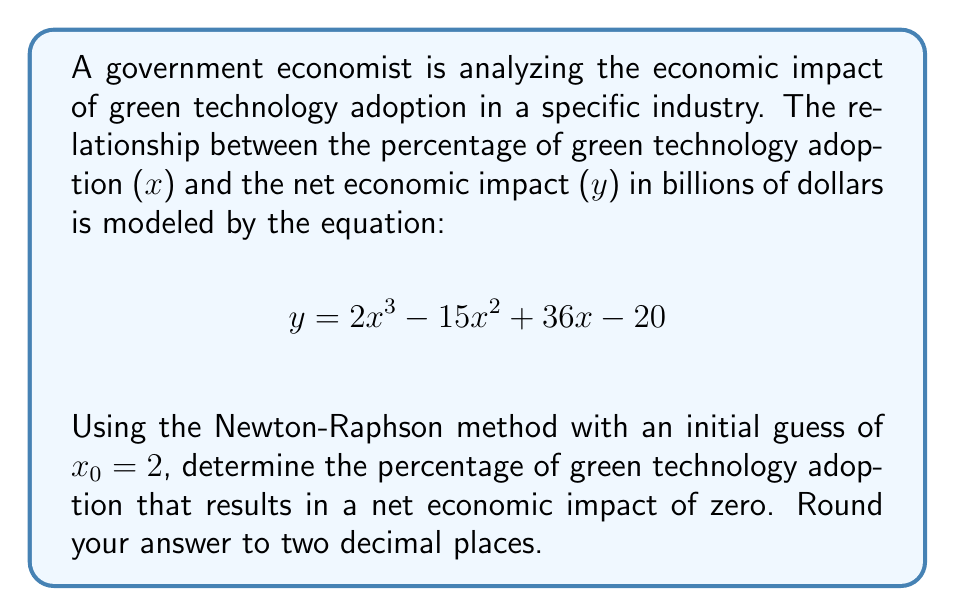Can you answer this question? To solve this problem using the Newton-Raphson method, we need to follow these steps:

1) First, we rewrite the equation to find the root:
   $$f(x) = 2x^3 - 15x^2 + 36x - 20 = 0$$

2) The derivative of f(x) is:
   $$f'(x) = 6x^2 - 30x + 36$$

3) The Newton-Raphson formula is:
   $$x_{n+1} = x_n - \frac{f(x_n)}{f'(x_n)}$$

4) Starting with x₀ = 2, we calculate:

   f(2) = 2(2³) - 15(2²) + 36(2) - 20 = 16 - 60 + 72 - 20 = 8
   f'(2) = 6(2²) - 30(2) + 36 = 24 - 60 + 36 = 0

5) Since f'(2) = 0, we can't use 2 as our initial guess. Let's try x₀ = 3:

   f(3) = 2(3³) - 15(3²) + 36(3) - 20 = 54 - 135 + 108 - 20 = 7
   f'(3) = 6(3²) - 30(3) + 36 = 54 - 90 + 36 = 0

6) Again, f'(3) = 0. Let's try x₀ = 1:

   f(1) = 2(1³) - 15(1²) + 36(1) - 20 = 2 - 15 + 36 - 20 = 3
   f'(1) = 6(1²) - 30(1) + 36 = 6 - 30 + 36 = 12

7) Now we can apply the Newton-Raphson formula:

   x₁ = 1 - (3/12) = 0.75

8) We continue this process:

   f(0.75) = 2(0.75³) - 15(0.75²) + 36(0.75) - 20 = 0.84375 - 8.4375 + 27 - 20 = -0.59375
   f'(0.75) = 6(0.75²) - 30(0.75) + 36 = 3.375 - 22.5 + 36 = 16.875

   x₂ = 0.75 - (-0.59375/16.875) = 0.7852

9) One more iteration:

   f(0.7852) ≈ -0.0004
   f'(0.7852) ≈ 17.5629

   x₃ = 0.7852 - (-0.0004/17.5629) ≈ 0.7852

The value has converged to four decimal places, so we can stop here.
Answer: 78.52% 